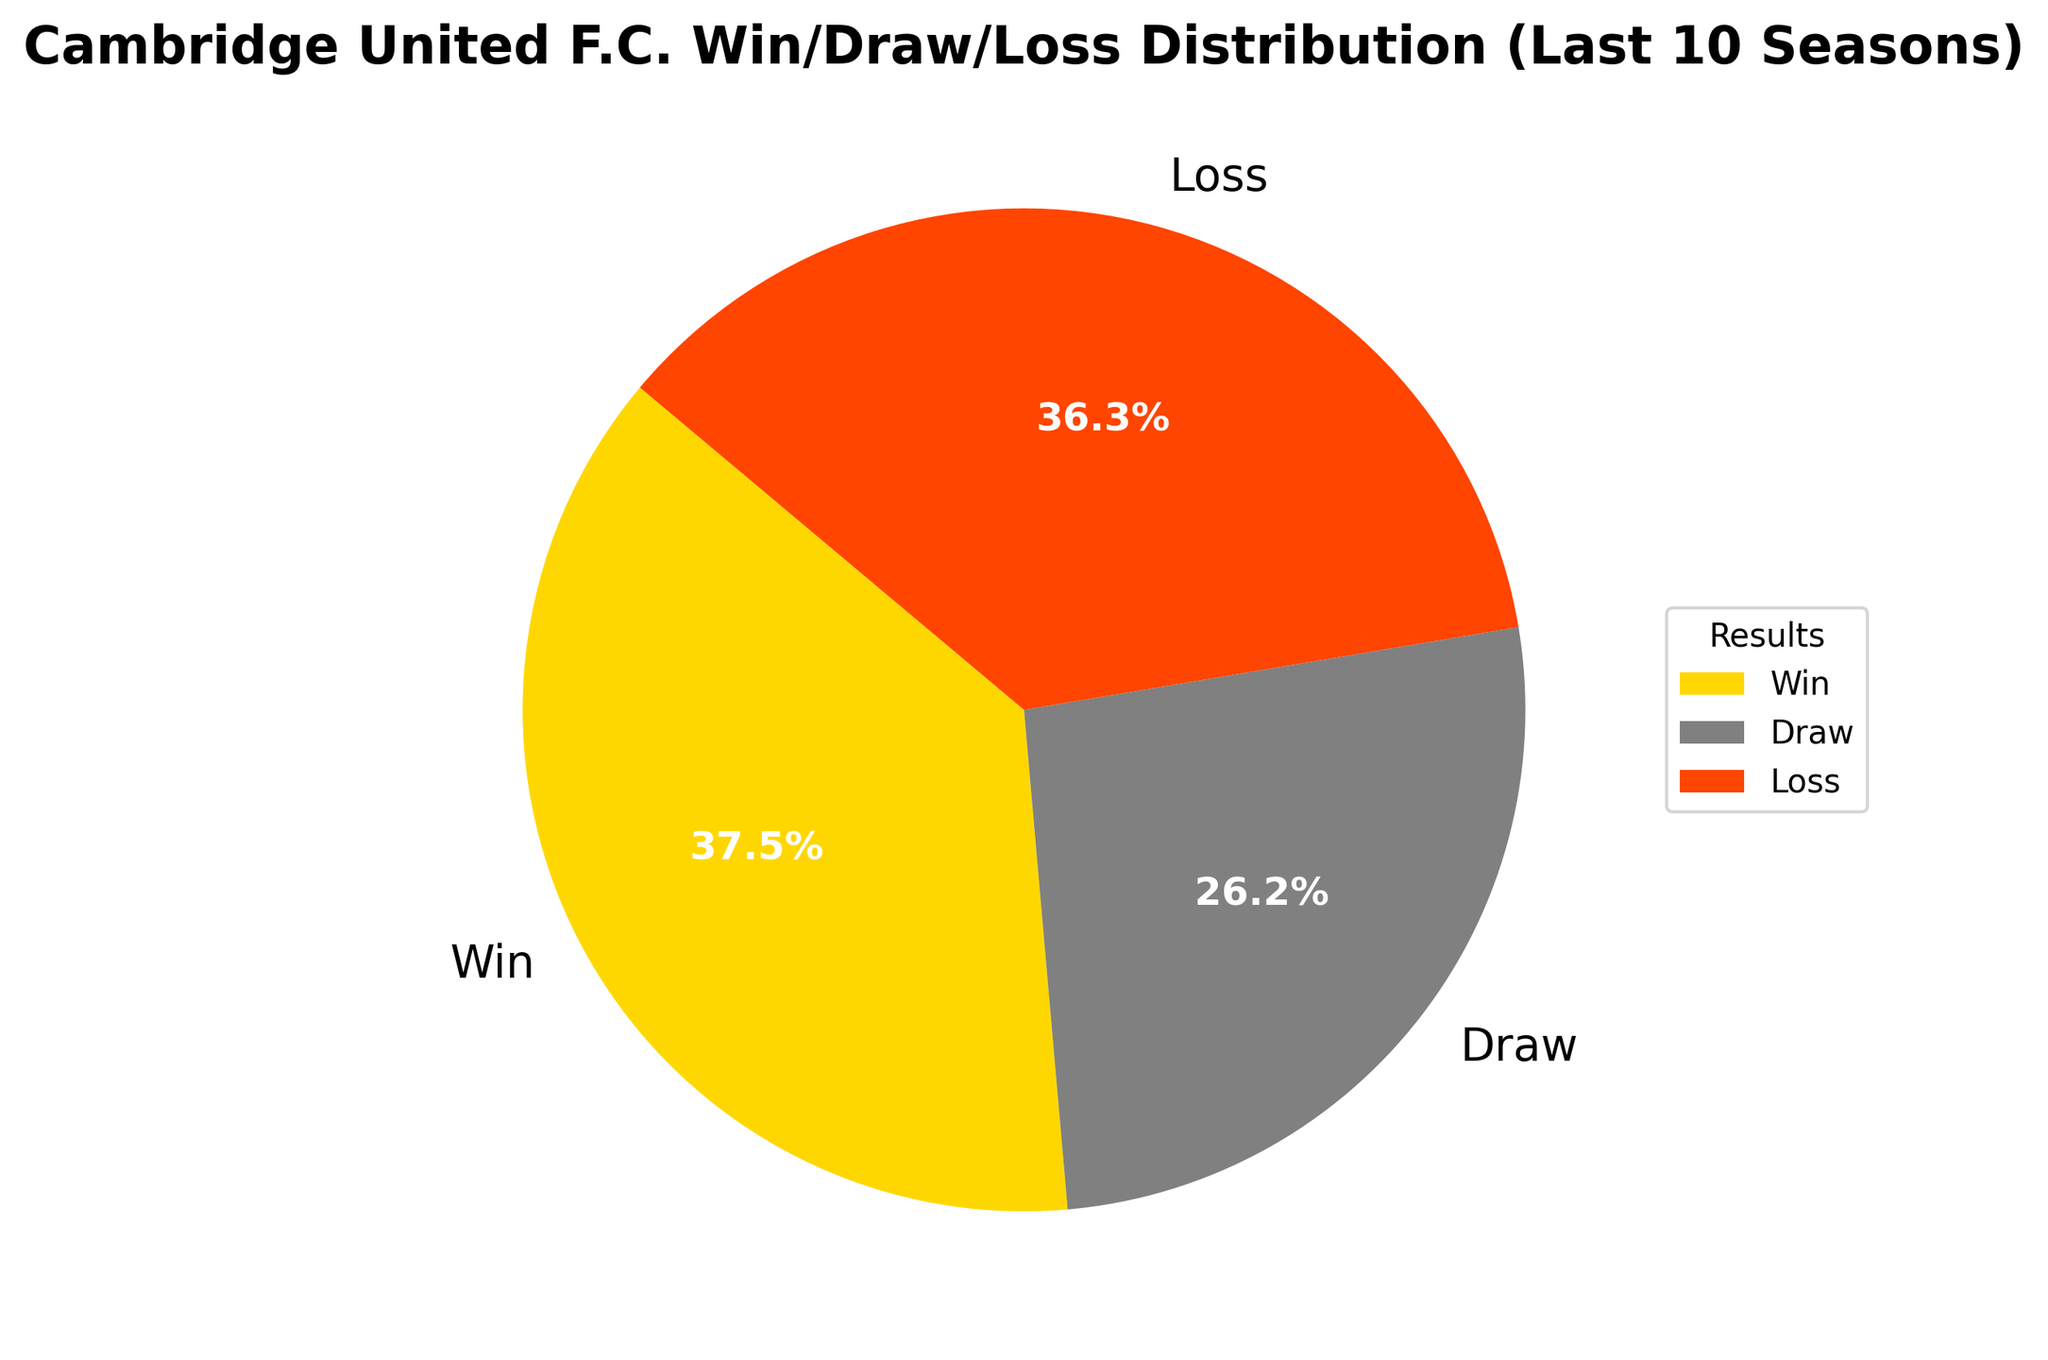what proportion of matches resulted in a win for Cambridge United? To find the proportion of matches that resulted in a win, first determine the total number of matches by summing up the counts for wins, draws, and losses. The total number of matches is 150 (Wins) + 105 (Draws) + 145 (Losses) = 400. The proportion of wins is the number of wins divided by the total number of matches, which equals 150/400. Simplifying, it is 37.5%.
Answer: 37.5% What is the most frequent match result for Cambridge United? By looking at the pie chart, it's clear that Wins, Draws, and Losses are represented as slices. The largest slice corresponds to Wins with a count of 150. Thus, the most frequent match result for Cambridge United is a win.
Answer: Win Which result form accounts for the smallest proportion of the matches? By comparing the sizes of the slices, Draws have the smallest slice. The count for Draws is 105, which is less than both Wins (150) and Losses (145). Therefore, Draws account for the smallest proportion of matches.
Answer: Draw What is the difference in the number of wins and losses for Cambridge United? To find the difference between the number of wins and losses, subtract the number of losses from the number of wins. The number of wins is 150, and the number of losses is 145. So, 150 - 145 gives us a difference of 5.
Answer: 5 What percentage of matches did Cambridge United not win? To find the percentage of matches not won, sum the counts of draws and losses and divide by the total number of matches. Draws are 105, and losses are 145, giving a total of 105 + 145 = 250 matches not won. Dividing this by the total number of matches (400) and multiplying by 100, we get (250/400) * 100 = 62.5%.
Answer: 62.5% If you combine the matches that ended in a draw or a loss, which category does this combined group fall into when compared to wins? First, sum the counts for draws and losses: 105 (Draws) + 145 (Losses) = 250. Compare this to the count for wins, which is 150. Since 250 is greater than 150, the combined group of draws and losses exceeds the number of wins.
Answer: Combined group (Draws + Losses) What is the ratio of wins to draws? To find the ratio of wins to draws, divide the count of wins by the count of draws. The count of wins is 150, and the count of draws is 105. The ratio is 150/105, which can be simplified by dividing both numbers by their greatest common divisor, which is 15: (150/15):(105/15) = 10:7.
Answer: 10:7 How many more wins does Cambridge United have compared to draws? To find how many more wins there are compared to draws, subtract the count of draws from the count of wins. The number of wins is 150, and the number of draws is 105. So, 150 - 105 equals 45 more wins.
Answer: 45 What fraction of the matches resulted in a draw? To find the fraction of matches that resulted in a draw, divide the count of draws by the total number of matches. The number of draws is 105, and the total number of matches is 400. Thus, the fraction is 105/400 which simplifies to 21/80.
Answer: 21/80 Which two result categories are closest in count, and what is their difference? To determine which two result categories are closest in count, find the differences between each pair of counts (Wins and Draws, Wins and Losses, Draws and Losses). The differences are: 150 (Wins) - 105 (Draws) = 45, 150 (Wins) - 145 (Losses) = 5, 145 (Losses) - 105 (Draws) = 40. The smallest difference is 5, which is between Wins (150) and Losses (145).
Answer: Wins and Losses, difference of 5 